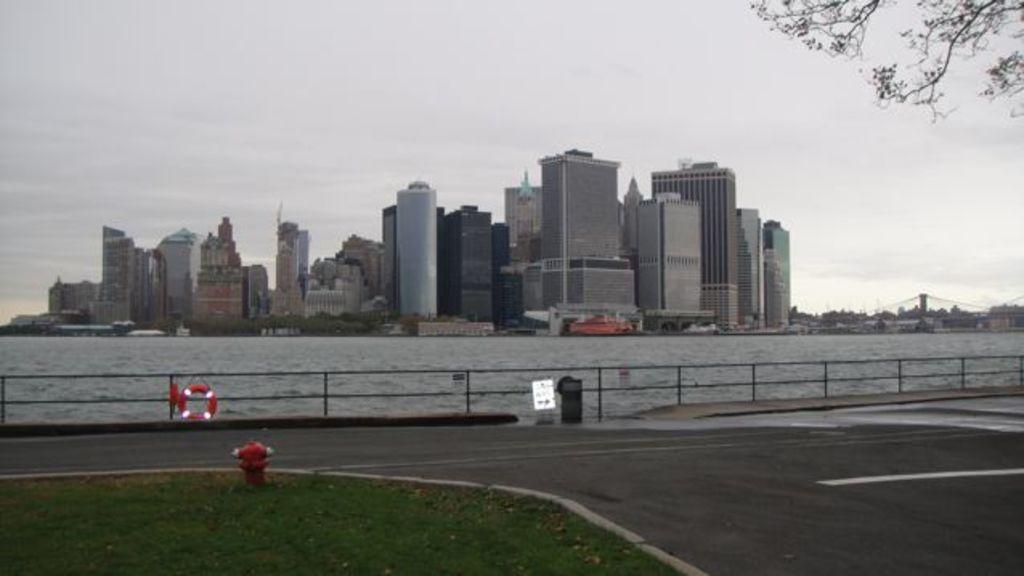What object is on the ground in the image? There is a hydrant on the ground in the image. What type of man-made structure can be seen in the image? There are buildings in the image. What type of natural environment can be seen in the image? There are trees in the image. What type of man-made path is visible in the image? There is a road visible in the image. What else can be seen in the image besides the hydrant, buildings, trees, and road? There are some objects in the image. What is visible in the background of the image? The sky is visible in the background of the image. What type of jelly is being served at the vacation spot in the image? There is no jelly or vacation spot present in the image; it features a hydrant, buildings, trees, and a road. How old is the boy in the image? There is no boy present in the image. 